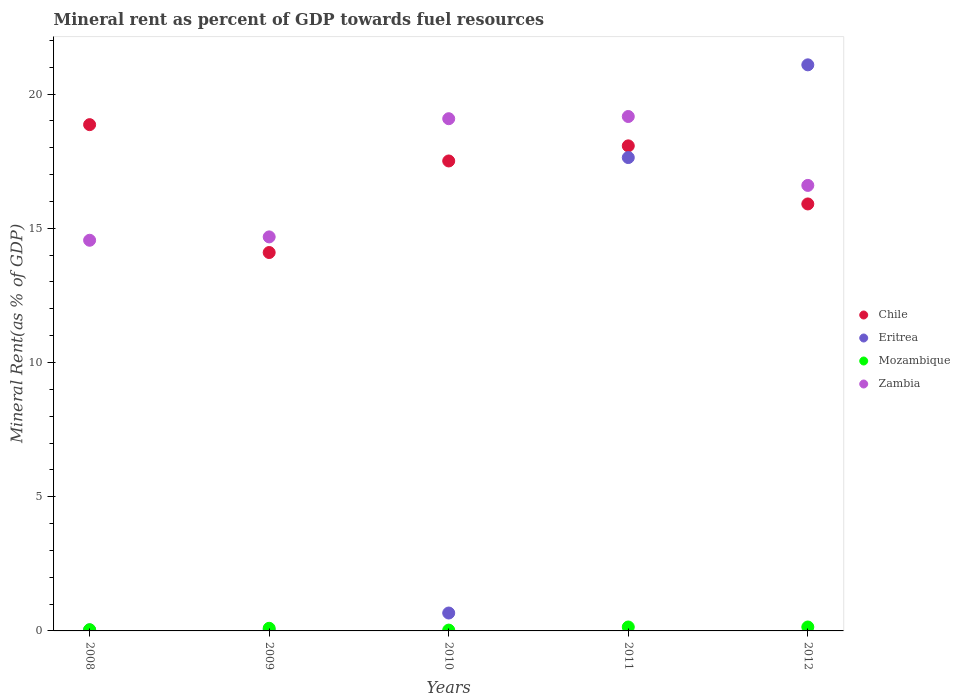What is the mineral rent in Chile in 2008?
Offer a terse response. 18.86. Across all years, what is the maximum mineral rent in Zambia?
Give a very brief answer. 19.16. Across all years, what is the minimum mineral rent in Zambia?
Your answer should be very brief. 14.55. In which year was the mineral rent in Mozambique maximum?
Your answer should be very brief. 2011. What is the total mineral rent in Zambia in the graph?
Your answer should be very brief. 84.07. What is the difference between the mineral rent in Mozambique in 2011 and that in 2012?
Your answer should be compact. 3.2200877973009856e-5. What is the difference between the mineral rent in Mozambique in 2009 and the mineral rent in Chile in 2010?
Offer a very short reply. -17.41. What is the average mineral rent in Mozambique per year?
Provide a succinct answer. 0.09. In the year 2010, what is the difference between the mineral rent in Chile and mineral rent in Zambia?
Ensure brevity in your answer.  -1.57. What is the ratio of the mineral rent in Eritrea in 2008 to that in 2011?
Give a very brief answer. 0. Is the mineral rent in Zambia in 2008 less than that in 2012?
Your answer should be compact. Yes. Is the difference between the mineral rent in Chile in 2008 and 2012 greater than the difference between the mineral rent in Zambia in 2008 and 2012?
Your answer should be very brief. Yes. What is the difference between the highest and the second highest mineral rent in Mozambique?
Provide a succinct answer. 3.2200877973009856e-5. What is the difference between the highest and the lowest mineral rent in Chile?
Your answer should be compact. 4.76. Is the sum of the mineral rent in Zambia in 2010 and 2011 greater than the maximum mineral rent in Eritrea across all years?
Your answer should be compact. Yes. Is the mineral rent in Mozambique strictly greater than the mineral rent in Chile over the years?
Offer a terse response. No. How many dotlines are there?
Your answer should be compact. 4. How many years are there in the graph?
Provide a succinct answer. 5. What is the difference between two consecutive major ticks on the Y-axis?
Offer a terse response. 5. How many legend labels are there?
Give a very brief answer. 4. How are the legend labels stacked?
Your answer should be compact. Vertical. What is the title of the graph?
Offer a terse response. Mineral rent as percent of GDP towards fuel resources. Does "Channel Islands" appear as one of the legend labels in the graph?
Ensure brevity in your answer.  No. What is the label or title of the X-axis?
Your answer should be compact. Years. What is the label or title of the Y-axis?
Your answer should be very brief. Mineral Rent(as % of GDP). What is the Mineral Rent(as % of GDP) of Chile in 2008?
Make the answer very short. 18.86. What is the Mineral Rent(as % of GDP) of Eritrea in 2008?
Your answer should be compact. 0.04. What is the Mineral Rent(as % of GDP) in Mozambique in 2008?
Ensure brevity in your answer.  0.05. What is the Mineral Rent(as % of GDP) of Zambia in 2008?
Your response must be concise. 14.55. What is the Mineral Rent(as % of GDP) of Chile in 2009?
Your answer should be very brief. 14.1. What is the Mineral Rent(as % of GDP) in Eritrea in 2009?
Ensure brevity in your answer.  0.03. What is the Mineral Rent(as % of GDP) in Mozambique in 2009?
Offer a terse response. 0.1. What is the Mineral Rent(as % of GDP) in Zambia in 2009?
Keep it short and to the point. 14.68. What is the Mineral Rent(as % of GDP) in Chile in 2010?
Offer a terse response. 17.51. What is the Mineral Rent(as % of GDP) of Eritrea in 2010?
Your answer should be very brief. 0.67. What is the Mineral Rent(as % of GDP) in Mozambique in 2010?
Provide a short and direct response. 0.03. What is the Mineral Rent(as % of GDP) of Zambia in 2010?
Provide a short and direct response. 19.08. What is the Mineral Rent(as % of GDP) of Chile in 2011?
Your response must be concise. 18.07. What is the Mineral Rent(as % of GDP) in Eritrea in 2011?
Offer a terse response. 17.63. What is the Mineral Rent(as % of GDP) in Mozambique in 2011?
Ensure brevity in your answer.  0.15. What is the Mineral Rent(as % of GDP) of Zambia in 2011?
Give a very brief answer. 19.16. What is the Mineral Rent(as % of GDP) of Chile in 2012?
Your response must be concise. 15.91. What is the Mineral Rent(as % of GDP) of Eritrea in 2012?
Offer a very short reply. 21.09. What is the Mineral Rent(as % of GDP) in Mozambique in 2012?
Your answer should be compact. 0.15. What is the Mineral Rent(as % of GDP) in Zambia in 2012?
Make the answer very short. 16.6. Across all years, what is the maximum Mineral Rent(as % of GDP) of Chile?
Keep it short and to the point. 18.86. Across all years, what is the maximum Mineral Rent(as % of GDP) of Eritrea?
Provide a short and direct response. 21.09. Across all years, what is the maximum Mineral Rent(as % of GDP) of Mozambique?
Give a very brief answer. 0.15. Across all years, what is the maximum Mineral Rent(as % of GDP) of Zambia?
Provide a succinct answer. 19.16. Across all years, what is the minimum Mineral Rent(as % of GDP) of Chile?
Your answer should be very brief. 14.1. Across all years, what is the minimum Mineral Rent(as % of GDP) of Eritrea?
Provide a succinct answer. 0.03. Across all years, what is the minimum Mineral Rent(as % of GDP) of Mozambique?
Ensure brevity in your answer.  0.03. Across all years, what is the minimum Mineral Rent(as % of GDP) in Zambia?
Ensure brevity in your answer.  14.55. What is the total Mineral Rent(as % of GDP) in Chile in the graph?
Keep it short and to the point. 84.44. What is the total Mineral Rent(as % of GDP) in Eritrea in the graph?
Offer a terse response. 39.46. What is the total Mineral Rent(as % of GDP) in Mozambique in the graph?
Offer a very short reply. 0.47. What is the total Mineral Rent(as % of GDP) in Zambia in the graph?
Keep it short and to the point. 84.07. What is the difference between the Mineral Rent(as % of GDP) of Chile in 2008 and that in 2009?
Your response must be concise. 4.76. What is the difference between the Mineral Rent(as % of GDP) in Eritrea in 2008 and that in 2009?
Give a very brief answer. 0. What is the difference between the Mineral Rent(as % of GDP) in Mozambique in 2008 and that in 2009?
Provide a short and direct response. -0.05. What is the difference between the Mineral Rent(as % of GDP) of Zambia in 2008 and that in 2009?
Your answer should be very brief. -0.13. What is the difference between the Mineral Rent(as % of GDP) in Chile in 2008 and that in 2010?
Give a very brief answer. 1.35. What is the difference between the Mineral Rent(as % of GDP) of Eritrea in 2008 and that in 2010?
Keep it short and to the point. -0.63. What is the difference between the Mineral Rent(as % of GDP) of Mozambique in 2008 and that in 2010?
Ensure brevity in your answer.  0.01. What is the difference between the Mineral Rent(as % of GDP) in Zambia in 2008 and that in 2010?
Your response must be concise. -4.53. What is the difference between the Mineral Rent(as % of GDP) of Chile in 2008 and that in 2011?
Ensure brevity in your answer.  0.79. What is the difference between the Mineral Rent(as % of GDP) of Eritrea in 2008 and that in 2011?
Offer a very short reply. -17.6. What is the difference between the Mineral Rent(as % of GDP) in Mozambique in 2008 and that in 2011?
Your answer should be very brief. -0.1. What is the difference between the Mineral Rent(as % of GDP) in Zambia in 2008 and that in 2011?
Give a very brief answer. -4.61. What is the difference between the Mineral Rent(as % of GDP) in Chile in 2008 and that in 2012?
Offer a very short reply. 2.95. What is the difference between the Mineral Rent(as % of GDP) in Eritrea in 2008 and that in 2012?
Offer a terse response. -21.05. What is the difference between the Mineral Rent(as % of GDP) of Mozambique in 2008 and that in 2012?
Make the answer very short. -0.1. What is the difference between the Mineral Rent(as % of GDP) of Zambia in 2008 and that in 2012?
Your response must be concise. -2.04. What is the difference between the Mineral Rent(as % of GDP) of Chile in 2009 and that in 2010?
Your answer should be compact. -3.41. What is the difference between the Mineral Rent(as % of GDP) in Eritrea in 2009 and that in 2010?
Keep it short and to the point. -0.63. What is the difference between the Mineral Rent(as % of GDP) in Mozambique in 2009 and that in 2010?
Ensure brevity in your answer.  0.07. What is the difference between the Mineral Rent(as % of GDP) in Zambia in 2009 and that in 2010?
Your answer should be compact. -4.4. What is the difference between the Mineral Rent(as % of GDP) in Chile in 2009 and that in 2011?
Ensure brevity in your answer.  -3.97. What is the difference between the Mineral Rent(as % of GDP) of Eritrea in 2009 and that in 2011?
Your answer should be very brief. -17.6. What is the difference between the Mineral Rent(as % of GDP) of Mozambique in 2009 and that in 2011?
Offer a terse response. -0.05. What is the difference between the Mineral Rent(as % of GDP) of Zambia in 2009 and that in 2011?
Provide a short and direct response. -4.48. What is the difference between the Mineral Rent(as % of GDP) of Chile in 2009 and that in 2012?
Make the answer very short. -1.81. What is the difference between the Mineral Rent(as % of GDP) in Eritrea in 2009 and that in 2012?
Your response must be concise. -21.05. What is the difference between the Mineral Rent(as % of GDP) in Mozambique in 2009 and that in 2012?
Keep it short and to the point. -0.05. What is the difference between the Mineral Rent(as % of GDP) of Zambia in 2009 and that in 2012?
Your response must be concise. -1.92. What is the difference between the Mineral Rent(as % of GDP) of Chile in 2010 and that in 2011?
Give a very brief answer. -0.56. What is the difference between the Mineral Rent(as % of GDP) in Eritrea in 2010 and that in 2011?
Ensure brevity in your answer.  -16.97. What is the difference between the Mineral Rent(as % of GDP) of Mozambique in 2010 and that in 2011?
Your response must be concise. -0.12. What is the difference between the Mineral Rent(as % of GDP) of Zambia in 2010 and that in 2011?
Ensure brevity in your answer.  -0.08. What is the difference between the Mineral Rent(as % of GDP) of Chile in 2010 and that in 2012?
Offer a terse response. 1.6. What is the difference between the Mineral Rent(as % of GDP) of Eritrea in 2010 and that in 2012?
Ensure brevity in your answer.  -20.42. What is the difference between the Mineral Rent(as % of GDP) of Mozambique in 2010 and that in 2012?
Make the answer very short. -0.12. What is the difference between the Mineral Rent(as % of GDP) in Zambia in 2010 and that in 2012?
Your response must be concise. 2.48. What is the difference between the Mineral Rent(as % of GDP) in Chile in 2011 and that in 2012?
Your response must be concise. 2.16. What is the difference between the Mineral Rent(as % of GDP) in Eritrea in 2011 and that in 2012?
Your response must be concise. -3.45. What is the difference between the Mineral Rent(as % of GDP) of Mozambique in 2011 and that in 2012?
Keep it short and to the point. 0. What is the difference between the Mineral Rent(as % of GDP) in Zambia in 2011 and that in 2012?
Provide a short and direct response. 2.57. What is the difference between the Mineral Rent(as % of GDP) of Chile in 2008 and the Mineral Rent(as % of GDP) of Eritrea in 2009?
Keep it short and to the point. 18.83. What is the difference between the Mineral Rent(as % of GDP) of Chile in 2008 and the Mineral Rent(as % of GDP) of Mozambique in 2009?
Your answer should be compact. 18.76. What is the difference between the Mineral Rent(as % of GDP) in Chile in 2008 and the Mineral Rent(as % of GDP) in Zambia in 2009?
Your response must be concise. 4.18. What is the difference between the Mineral Rent(as % of GDP) in Eritrea in 2008 and the Mineral Rent(as % of GDP) in Mozambique in 2009?
Your answer should be very brief. -0.06. What is the difference between the Mineral Rent(as % of GDP) of Eritrea in 2008 and the Mineral Rent(as % of GDP) of Zambia in 2009?
Provide a succinct answer. -14.64. What is the difference between the Mineral Rent(as % of GDP) in Mozambique in 2008 and the Mineral Rent(as % of GDP) in Zambia in 2009?
Give a very brief answer. -14.63. What is the difference between the Mineral Rent(as % of GDP) in Chile in 2008 and the Mineral Rent(as % of GDP) in Eritrea in 2010?
Your answer should be compact. 18.19. What is the difference between the Mineral Rent(as % of GDP) in Chile in 2008 and the Mineral Rent(as % of GDP) in Mozambique in 2010?
Offer a terse response. 18.83. What is the difference between the Mineral Rent(as % of GDP) in Chile in 2008 and the Mineral Rent(as % of GDP) in Zambia in 2010?
Make the answer very short. -0.22. What is the difference between the Mineral Rent(as % of GDP) in Eritrea in 2008 and the Mineral Rent(as % of GDP) in Mozambique in 2010?
Give a very brief answer. 0.01. What is the difference between the Mineral Rent(as % of GDP) in Eritrea in 2008 and the Mineral Rent(as % of GDP) in Zambia in 2010?
Make the answer very short. -19.05. What is the difference between the Mineral Rent(as % of GDP) in Mozambique in 2008 and the Mineral Rent(as % of GDP) in Zambia in 2010?
Offer a terse response. -19.04. What is the difference between the Mineral Rent(as % of GDP) in Chile in 2008 and the Mineral Rent(as % of GDP) in Eritrea in 2011?
Ensure brevity in your answer.  1.23. What is the difference between the Mineral Rent(as % of GDP) of Chile in 2008 and the Mineral Rent(as % of GDP) of Mozambique in 2011?
Your response must be concise. 18.71. What is the difference between the Mineral Rent(as % of GDP) in Chile in 2008 and the Mineral Rent(as % of GDP) in Zambia in 2011?
Provide a short and direct response. -0.3. What is the difference between the Mineral Rent(as % of GDP) in Eritrea in 2008 and the Mineral Rent(as % of GDP) in Mozambique in 2011?
Offer a terse response. -0.11. What is the difference between the Mineral Rent(as % of GDP) of Eritrea in 2008 and the Mineral Rent(as % of GDP) of Zambia in 2011?
Ensure brevity in your answer.  -19.13. What is the difference between the Mineral Rent(as % of GDP) in Mozambique in 2008 and the Mineral Rent(as % of GDP) in Zambia in 2011?
Your answer should be very brief. -19.12. What is the difference between the Mineral Rent(as % of GDP) in Chile in 2008 and the Mineral Rent(as % of GDP) in Eritrea in 2012?
Ensure brevity in your answer.  -2.23. What is the difference between the Mineral Rent(as % of GDP) of Chile in 2008 and the Mineral Rent(as % of GDP) of Mozambique in 2012?
Give a very brief answer. 18.71. What is the difference between the Mineral Rent(as % of GDP) in Chile in 2008 and the Mineral Rent(as % of GDP) in Zambia in 2012?
Provide a short and direct response. 2.26. What is the difference between the Mineral Rent(as % of GDP) of Eritrea in 2008 and the Mineral Rent(as % of GDP) of Mozambique in 2012?
Your answer should be compact. -0.11. What is the difference between the Mineral Rent(as % of GDP) in Eritrea in 2008 and the Mineral Rent(as % of GDP) in Zambia in 2012?
Your response must be concise. -16.56. What is the difference between the Mineral Rent(as % of GDP) of Mozambique in 2008 and the Mineral Rent(as % of GDP) of Zambia in 2012?
Your answer should be compact. -16.55. What is the difference between the Mineral Rent(as % of GDP) in Chile in 2009 and the Mineral Rent(as % of GDP) in Eritrea in 2010?
Keep it short and to the point. 13.43. What is the difference between the Mineral Rent(as % of GDP) of Chile in 2009 and the Mineral Rent(as % of GDP) of Mozambique in 2010?
Your answer should be compact. 14.07. What is the difference between the Mineral Rent(as % of GDP) in Chile in 2009 and the Mineral Rent(as % of GDP) in Zambia in 2010?
Offer a terse response. -4.98. What is the difference between the Mineral Rent(as % of GDP) in Eritrea in 2009 and the Mineral Rent(as % of GDP) in Mozambique in 2010?
Your answer should be compact. 0. What is the difference between the Mineral Rent(as % of GDP) in Eritrea in 2009 and the Mineral Rent(as % of GDP) in Zambia in 2010?
Make the answer very short. -19.05. What is the difference between the Mineral Rent(as % of GDP) of Mozambique in 2009 and the Mineral Rent(as % of GDP) of Zambia in 2010?
Provide a succinct answer. -18.98. What is the difference between the Mineral Rent(as % of GDP) in Chile in 2009 and the Mineral Rent(as % of GDP) in Eritrea in 2011?
Offer a very short reply. -3.54. What is the difference between the Mineral Rent(as % of GDP) of Chile in 2009 and the Mineral Rent(as % of GDP) of Mozambique in 2011?
Provide a short and direct response. 13.95. What is the difference between the Mineral Rent(as % of GDP) in Chile in 2009 and the Mineral Rent(as % of GDP) in Zambia in 2011?
Your answer should be compact. -5.07. What is the difference between the Mineral Rent(as % of GDP) of Eritrea in 2009 and the Mineral Rent(as % of GDP) of Mozambique in 2011?
Your answer should be compact. -0.11. What is the difference between the Mineral Rent(as % of GDP) of Eritrea in 2009 and the Mineral Rent(as % of GDP) of Zambia in 2011?
Offer a terse response. -19.13. What is the difference between the Mineral Rent(as % of GDP) of Mozambique in 2009 and the Mineral Rent(as % of GDP) of Zambia in 2011?
Keep it short and to the point. -19.06. What is the difference between the Mineral Rent(as % of GDP) in Chile in 2009 and the Mineral Rent(as % of GDP) in Eritrea in 2012?
Ensure brevity in your answer.  -6.99. What is the difference between the Mineral Rent(as % of GDP) in Chile in 2009 and the Mineral Rent(as % of GDP) in Mozambique in 2012?
Give a very brief answer. 13.95. What is the difference between the Mineral Rent(as % of GDP) of Chile in 2009 and the Mineral Rent(as % of GDP) of Zambia in 2012?
Provide a succinct answer. -2.5. What is the difference between the Mineral Rent(as % of GDP) of Eritrea in 2009 and the Mineral Rent(as % of GDP) of Mozambique in 2012?
Offer a terse response. -0.11. What is the difference between the Mineral Rent(as % of GDP) of Eritrea in 2009 and the Mineral Rent(as % of GDP) of Zambia in 2012?
Your answer should be very brief. -16.56. What is the difference between the Mineral Rent(as % of GDP) of Mozambique in 2009 and the Mineral Rent(as % of GDP) of Zambia in 2012?
Ensure brevity in your answer.  -16.5. What is the difference between the Mineral Rent(as % of GDP) of Chile in 2010 and the Mineral Rent(as % of GDP) of Eritrea in 2011?
Keep it short and to the point. -0.13. What is the difference between the Mineral Rent(as % of GDP) of Chile in 2010 and the Mineral Rent(as % of GDP) of Mozambique in 2011?
Provide a succinct answer. 17.36. What is the difference between the Mineral Rent(as % of GDP) of Chile in 2010 and the Mineral Rent(as % of GDP) of Zambia in 2011?
Provide a short and direct response. -1.66. What is the difference between the Mineral Rent(as % of GDP) of Eritrea in 2010 and the Mineral Rent(as % of GDP) of Mozambique in 2011?
Your answer should be compact. 0.52. What is the difference between the Mineral Rent(as % of GDP) of Eritrea in 2010 and the Mineral Rent(as % of GDP) of Zambia in 2011?
Offer a terse response. -18.5. What is the difference between the Mineral Rent(as % of GDP) of Mozambique in 2010 and the Mineral Rent(as % of GDP) of Zambia in 2011?
Provide a succinct answer. -19.13. What is the difference between the Mineral Rent(as % of GDP) in Chile in 2010 and the Mineral Rent(as % of GDP) in Eritrea in 2012?
Your response must be concise. -3.58. What is the difference between the Mineral Rent(as % of GDP) of Chile in 2010 and the Mineral Rent(as % of GDP) of Mozambique in 2012?
Give a very brief answer. 17.36. What is the difference between the Mineral Rent(as % of GDP) of Chile in 2010 and the Mineral Rent(as % of GDP) of Zambia in 2012?
Make the answer very short. 0.91. What is the difference between the Mineral Rent(as % of GDP) of Eritrea in 2010 and the Mineral Rent(as % of GDP) of Mozambique in 2012?
Give a very brief answer. 0.52. What is the difference between the Mineral Rent(as % of GDP) in Eritrea in 2010 and the Mineral Rent(as % of GDP) in Zambia in 2012?
Offer a very short reply. -15.93. What is the difference between the Mineral Rent(as % of GDP) of Mozambique in 2010 and the Mineral Rent(as % of GDP) of Zambia in 2012?
Offer a very short reply. -16.57. What is the difference between the Mineral Rent(as % of GDP) of Chile in 2011 and the Mineral Rent(as % of GDP) of Eritrea in 2012?
Your answer should be compact. -3.02. What is the difference between the Mineral Rent(as % of GDP) in Chile in 2011 and the Mineral Rent(as % of GDP) in Mozambique in 2012?
Make the answer very short. 17.92. What is the difference between the Mineral Rent(as % of GDP) in Chile in 2011 and the Mineral Rent(as % of GDP) in Zambia in 2012?
Offer a very short reply. 1.47. What is the difference between the Mineral Rent(as % of GDP) in Eritrea in 2011 and the Mineral Rent(as % of GDP) in Mozambique in 2012?
Offer a terse response. 17.49. What is the difference between the Mineral Rent(as % of GDP) in Eritrea in 2011 and the Mineral Rent(as % of GDP) in Zambia in 2012?
Offer a very short reply. 1.04. What is the difference between the Mineral Rent(as % of GDP) of Mozambique in 2011 and the Mineral Rent(as % of GDP) of Zambia in 2012?
Your answer should be compact. -16.45. What is the average Mineral Rent(as % of GDP) in Chile per year?
Your response must be concise. 16.89. What is the average Mineral Rent(as % of GDP) of Eritrea per year?
Offer a terse response. 7.89. What is the average Mineral Rent(as % of GDP) of Mozambique per year?
Offer a terse response. 0.09. What is the average Mineral Rent(as % of GDP) in Zambia per year?
Make the answer very short. 16.81. In the year 2008, what is the difference between the Mineral Rent(as % of GDP) of Chile and Mineral Rent(as % of GDP) of Eritrea?
Offer a very short reply. 18.82. In the year 2008, what is the difference between the Mineral Rent(as % of GDP) of Chile and Mineral Rent(as % of GDP) of Mozambique?
Keep it short and to the point. 18.81. In the year 2008, what is the difference between the Mineral Rent(as % of GDP) of Chile and Mineral Rent(as % of GDP) of Zambia?
Provide a short and direct response. 4.31. In the year 2008, what is the difference between the Mineral Rent(as % of GDP) of Eritrea and Mineral Rent(as % of GDP) of Mozambique?
Keep it short and to the point. -0.01. In the year 2008, what is the difference between the Mineral Rent(as % of GDP) in Eritrea and Mineral Rent(as % of GDP) in Zambia?
Offer a very short reply. -14.52. In the year 2008, what is the difference between the Mineral Rent(as % of GDP) in Mozambique and Mineral Rent(as % of GDP) in Zambia?
Provide a short and direct response. -14.51. In the year 2009, what is the difference between the Mineral Rent(as % of GDP) in Chile and Mineral Rent(as % of GDP) in Eritrea?
Make the answer very short. 14.06. In the year 2009, what is the difference between the Mineral Rent(as % of GDP) in Chile and Mineral Rent(as % of GDP) in Mozambique?
Provide a short and direct response. 14. In the year 2009, what is the difference between the Mineral Rent(as % of GDP) in Chile and Mineral Rent(as % of GDP) in Zambia?
Your response must be concise. -0.58. In the year 2009, what is the difference between the Mineral Rent(as % of GDP) in Eritrea and Mineral Rent(as % of GDP) in Mozambique?
Offer a terse response. -0.07. In the year 2009, what is the difference between the Mineral Rent(as % of GDP) of Eritrea and Mineral Rent(as % of GDP) of Zambia?
Your response must be concise. -14.65. In the year 2009, what is the difference between the Mineral Rent(as % of GDP) in Mozambique and Mineral Rent(as % of GDP) in Zambia?
Your answer should be compact. -14.58. In the year 2010, what is the difference between the Mineral Rent(as % of GDP) in Chile and Mineral Rent(as % of GDP) in Eritrea?
Give a very brief answer. 16.84. In the year 2010, what is the difference between the Mineral Rent(as % of GDP) of Chile and Mineral Rent(as % of GDP) of Mozambique?
Ensure brevity in your answer.  17.48. In the year 2010, what is the difference between the Mineral Rent(as % of GDP) of Chile and Mineral Rent(as % of GDP) of Zambia?
Offer a terse response. -1.57. In the year 2010, what is the difference between the Mineral Rent(as % of GDP) in Eritrea and Mineral Rent(as % of GDP) in Mozambique?
Your answer should be very brief. 0.64. In the year 2010, what is the difference between the Mineral Rent(as % of GDP) of Eritrea and Mineral Rent(as % of GDP) of Zambia?
Keep it short and to the point. -18.41. In the year 2010, what is the difference between the Mineral Rent(as % of GDP) in Mozambique and Mineral Rent(as % of GDP) in Zambia?
Your answer should be compact. -19.05. In the year 2011, what is the difference between the Mineral Rent(as % of GDP) of Chile and Mineral Rent(as % of GDP) of Eritrea?
Provide a succinct answer. 0.44. In the year 2011, what is the difference between the Mineral Rent(as % of GDP) of Chile and Mineral Rent(as % of GDP) of Mozambique?
Provide a succinct answer. 17.92. In the year 2011, what is the difference between the Mineral Rent(as % of GDP) of Chile and Mineral Rent(as % of GDP) of Zambia?
Your answer should be very brief. -1.09. In the year 2011, what is the difference between the Mineral Rent(as % of GDP) of Eritrea and Mineral Rent(as % of GDP) of Mozambique?
Make the answer very short. 17.49. In the year 2011, what is the difference between the Mineral Rent(as % of GDP) of Eritrea and Mineral Rent(as % of GDP) of Zambia?
Provide a succinct answer. -1.53. In the year 2011, what is the difference between the Mineral Rent(as % of GDP) in Mozambique and Mineral Rent(as % of GDP) in Zambia?
Provide a short and direct response. -19.02. In the year 2012, what is the difference between the Mineral Rent(as % of GDP) in Chile and Mineral Rent(as % of GDP) in Eritrea?
Keep it short and to the point. -5.18. In the year 2012, what is the difference between the Mineral Rent(as % of GDP) of Chile and Mineral Rent(as % of GDP) of Mozambique?
Make the answer very short. 15.76. In the year 2012, what is the difference between the Mineral Rent(as % of GDP) in Chile and Mineral Rent(as % of GDP) in Zambia?
Offer a terse response. -0.69. In the year 2012, what is the difference between the Mineral Rent(as % of GDP) in Eritrea and Mineral Rent(as % of GDP) in Mozambique?
Give a very brief answer. 20.94. In the year 2012, what is the difference between the Mineral Rent(as % of GDP) in Eritrea and Mineral Rent(as % of GDP) in Zambia?
Offer a very short reply. 4.49. In the year 2012, what is the difference between the Mineral Rent(as % of GDP) in Mozambique and Mineral Rent(as % of GDP) in Zambia?
Provide a short and direct response. -16.45. What is the ratio of the Mineral Rent(as % of GDP) of Chile in 2008 to that in 2009?
Offer a very short reply. 1.34. What is the ratio of the Mineral Rent(as % of GDP) of Eritrea in 2008 to that in 2009?
Your response must be concise. 1.09. What is the ratio of the Mineral Rent(as % of GDP) in Mozambique in 2008 to that in 2009?
Offer a very short reply. 0.46. What is the ratio of the Mineral Rent(as % of GDP) in Chile in 2008 to that in 2010?
Your response must be concise. 1.08. What is the ratio of the Mineral Rent(as % of GDP) in Eritrea in 2008 to that in 2010?
Provide a short and direct response. 0.05. What is the ratio of the Mineral Rent(as % of GDP) of Mozambique in 2008 to that in 2010?
Keep it short and to the point. 1.48. What is the ratio of the Mineral Rent(as % of GDP) of Zambia in 2008 to that in 2010?
Provide a succinct answer. 0.76. What is the ratio of the Mineral Rent(as % of GDP) of Chile in 2008 to that in 2011?
Give a very brief answer. 1.04. What is the ratio of the Mineral Rent(as % of GDP) in Eritrea in 2008 to that in 2011?
Your answer should be compact. 0. What is the ratio of the Mineral Rent(as % of GDP) of Mozambique in 2008 to that in 2011?
Your answer should be very brief. 0.31. What is the ratio of the Mineral Rent(as % of GDP) of Zambia in 2008 to that in 2011?
Offer a very short reply. 0.76. What is the ratio of the Mineral Rent(as % of GDP) of Chile in 2008 to that in 2012?
Your response must be concise. 1.19. What is the ratio of the Mineral Rent(as % of GDP) of Eritrea in 2008 to that in 2012?
Make the answer very short. 0. What is the ratio of the Mineral Rent(as % of GDP) of Mozambique in 2008 to that in 2012?
Your answer should be very brief. 0.31. What is the ratio of the Mineral Rent(as % of GDP) of Zambia in 2008 to that in 2012?
Ensure brevity in your answer.  0.88. What is the ratio of the Mineral Rent(as % of GDP) of Chile in 2009 to that in 2010?
Provide a short and direct response. 0.81. What is the ratio of the Mineral Rent(as % of GDP) of Eritrea in 2009 to that in 2010?
Ensure brevity in your answer.  0.05. What is the ratio of the Mineral Rent(as % of GDP) in Mozambique in 2009 to that in 2010?
Give a very brief answer. 3.23. What is the ratio of the Mineral Rent(as % of GDP) of Zambia in 2009 to that in 2010?
Provide a short and direct response. 0.77. What is the ratio of the Mineral Rent(as % of GDP) in Chile in 2009 to that in 2011?
Keep it short and to the point. 0.78. What is the ratio of the Mineral Rent(as % of GDP) in Eritrea in 2009 to that in 2011?
Your answer should be very brief. 0. What is the ratio of the Mineral Rent(as % of GDP) of Mozambique in 2009 to that in 2011?
Ensure brevity in your answer.  0.67. What is the ratio of the Mineral Rent(as % of GDP) in Zambia in 2009 to that in 2011?
Make the answer very short. 0.77. What is the ratio of the Mineral Rent(as % of GDP) in Chile in 2009 to that in 2012?
Your answer should be very brief. 0.89. What is the ratio of the Mineral Rent(as % of GDP) of Eritrea in 2009 to that in 2012?
Ensure brevity in your answer.  0. What is the ratio of the Mineral Rent(as % of GDP) of Mozambique in 2009 to that in 2012?
Offer a terse response. 0.67. What is the ratio of the Mineral Rent(as % of GDP) of Zambia in 2009 to that in 2012?
Your response must be concise. 0.88. What is the ratio of the Mineral Rent(as % of GDP) in Chile in 2010 to that in 2011?
Your answer should be very brief. 0.97. What is the ratio of the Mineral Rent(as % of GDP) in Eritrea in 2010 to that in 2011?
Ensure brevity in your answer.  0.04. What is the ratio of the Mineral Rent(as % of GDP) in Mozambique in 2010 to that in 2011?
Ensure brevity in your answer.  0.21. What is the ratio of the Mineral Rent(as % of GDP) of Chile in 2010 to that in 2012?
Your answer should be compact. 1.1. What is the ratio of the Mineral Rent(as % of GDP) in Eritrea in 2010 to that in 2012?
Keep it short and to the point. 0.03. What is the ratio of the Mineral Rent(as % of GDP) of Mozambique in 2010 to that in 2012?
Provide a short and direct response. 0.21. What is the ratio of the Mineral Rent(as % of GDP) in Zambia in 2010 to that in 2012?
Ensure brevity in your answer.  1.15. What is the ratio of the Mineral Rent(as % of GDP) of Chile in 2011 to that in 2012?
Make the answer very short. 1.14. What is the ratio of the Mineral Rent(as % of GDP) of Eritrea in 2011 to that in 2012?
Offer a very short reply. 0.84. What is the ratio of the Mineral Rent(as % of GDP) of Mozambique in 2011 to that in 2012?
Keep it short and to the point. 1. What is the ratio of the Mineral Rent(as % of GDP) of Zambia in 2011 to that in 2012?
Your answer should be compact. 1.15. What is the difference between the highest and the second highest Mineral Rent(as % of GDP) of Chile?
Provide a succinct answer. 0.79. What is the difference between the highest and the second highest Mineral Rent(as % of GDP) of Eritrea?
Your response must be concise. 3.45. What is the difference between the highest and the second highest Mineral Rent(as % of GDP) in Zambia?
Keep it short and to the point. 0.08. What is the difference between the highest and the lowest Mineral Rent(as % of GDP) of Chile?
Your answer should be compact. 4.76. What is the difference between the highest and the lowest Mineral Rent(as % of GDP) of Eritrea?
Offer a terse response. 21.05. What is the difference between the highest and the lowest Mineral Rent(as % of GDP) of Mozambique?
Your answer should be compact. 0.12. What is the difference between the highest and the lowest Mineral Rent(as % of GDP) in Zambia?
Make the answer very short. 4.61. 